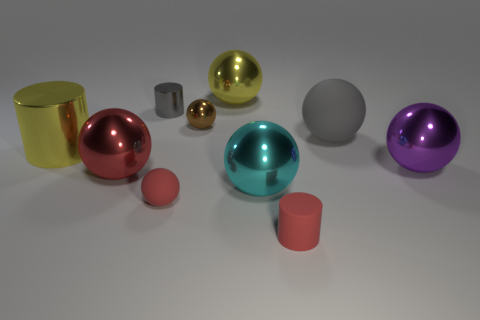Subtract all large cylinders. How many cylinders are left? 2 Subtract all green blocks. How many red spheres are left? 2 Subtract all yellow cylinders. How many cylinders are left? 2 Subtract all cylinders. How many objects are left? 7 Subtract 1 spheres. How many spheres are left? 6 Subtract all yellow spheres. Subtract all yellow cylinders. How many spheres are left? 6 Subtract all rubber cylinders. Subtract all big red metallic things. How many objects are left? 8 Add 6 gray spheres. How many gray spheres are left? 7 Add 4 tiny cylinders. How many tiny cylinders exist? 6 Subtract 0 cyan cubes. How many objects are left? 10 